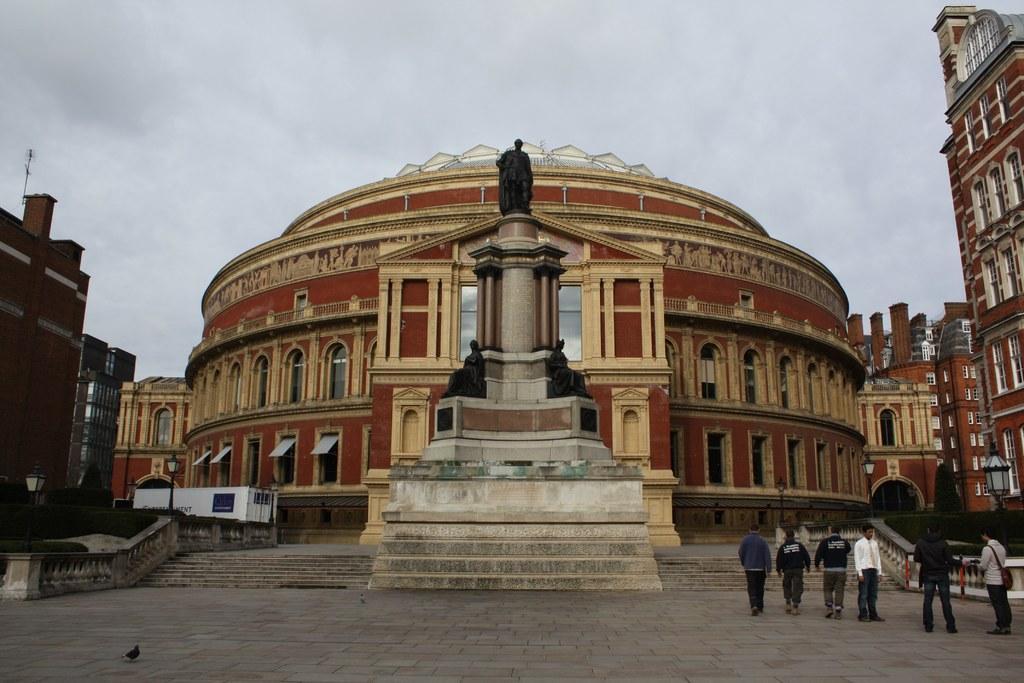How would you summarize this image in a sentence or two? In the picture we can see a round building with many windows to it and near to it we can see some sculptures on the stone and beside it we can see some people are walking on the path and besides the building we can also see railings and steps and around the buildings we can see another buildings and in the background we can see a sky with clouds. 